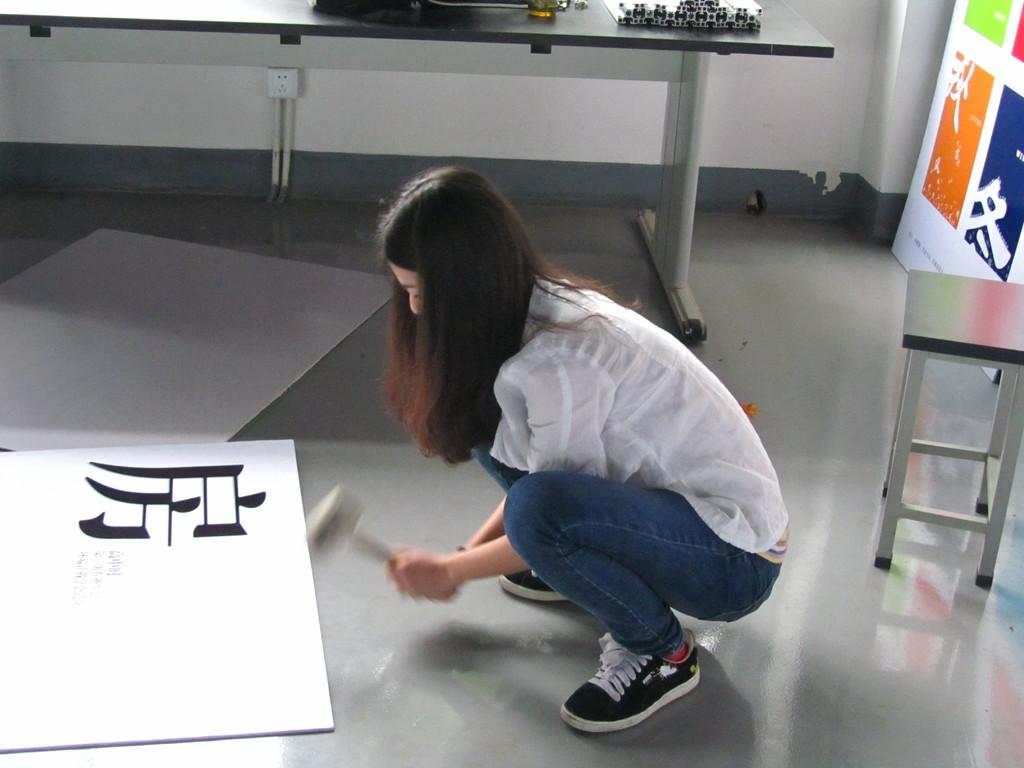Who is the main subject in the image? There is a woman in the image. What is the woman doing in the image? The woman is sitting and watching a paper. What type of shirt is the woman wearing in the image? The provided facts do not mention the woman's shirt, so we cannot determine the type of shirt she is wearing. What things can be seen floating in the soup in the image? There is no soup present in the image, so we cannot determine what things might be floating in it. 